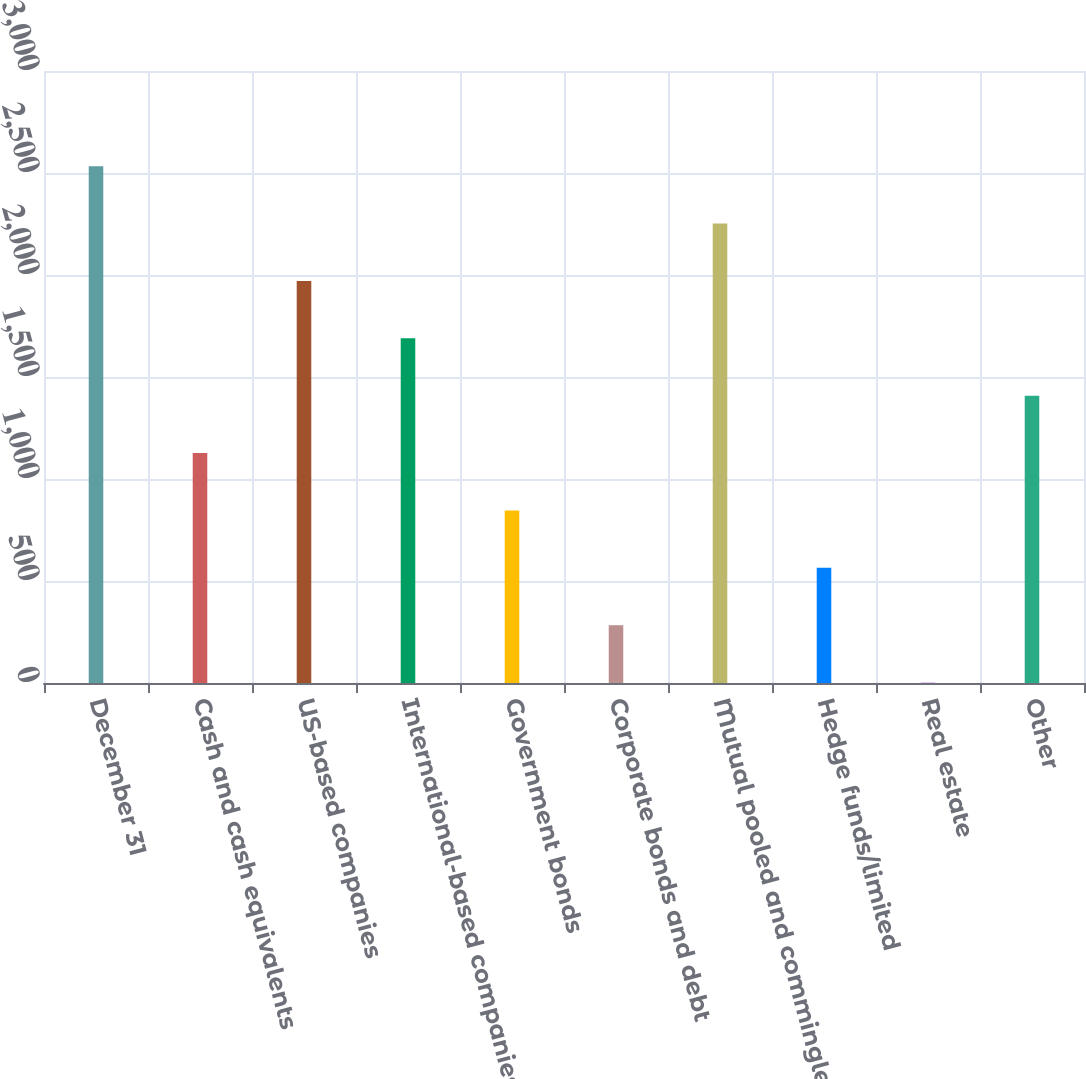Convert chart. <chart><loc_0><loc_0><loc_500><loc_500><bar_chart><fcel>December 31<fcel>Cash and cash equivalents<fcel>US-based companies<fcel>International-based companies<fcel>Government bonds<fcel>Corporate bonds and debt<fcel>Mutual pooled and commingled<fcel>Hedge funds/limited<fcel>Real estate<fcel>Other<nl><fcel>2533.7<fcel>1127.2<fcel>1971.1<fcel>1689.8<fcel>845.9<fcel>283.3<fcel>2252.4<fcel>564.6<fcel>2<fcel>1408.5<nl></chart> 